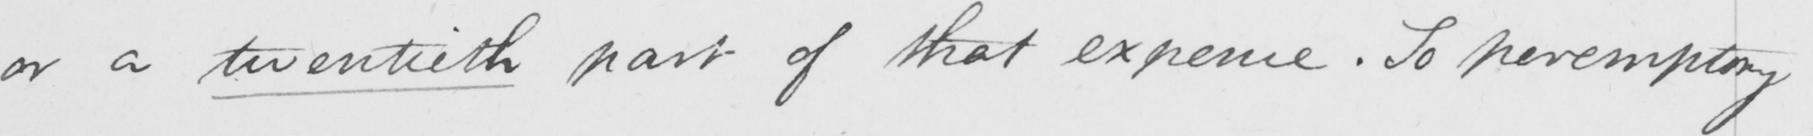Can you read and transcribe this handwriting? or a twentieth part of that expence . So peremptory 